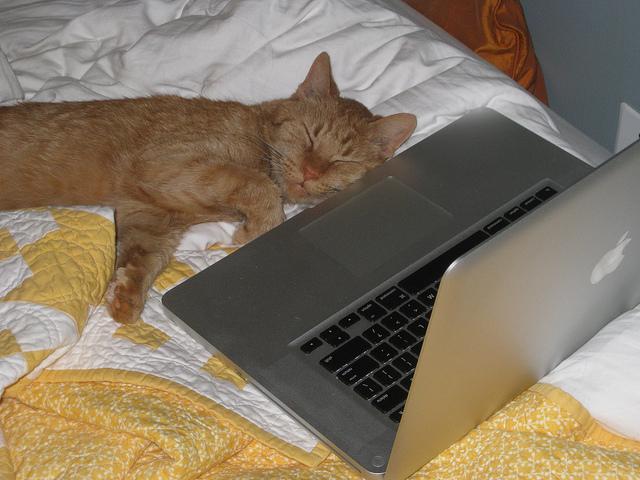Is the tabby tabbing?
Quick response, please. No. How many paws do you see?
Write a very short answer. 2. Is the cat using the computer?
Answer briefly. No. What black item is lying beside the computer?
Concise answer only. None. 